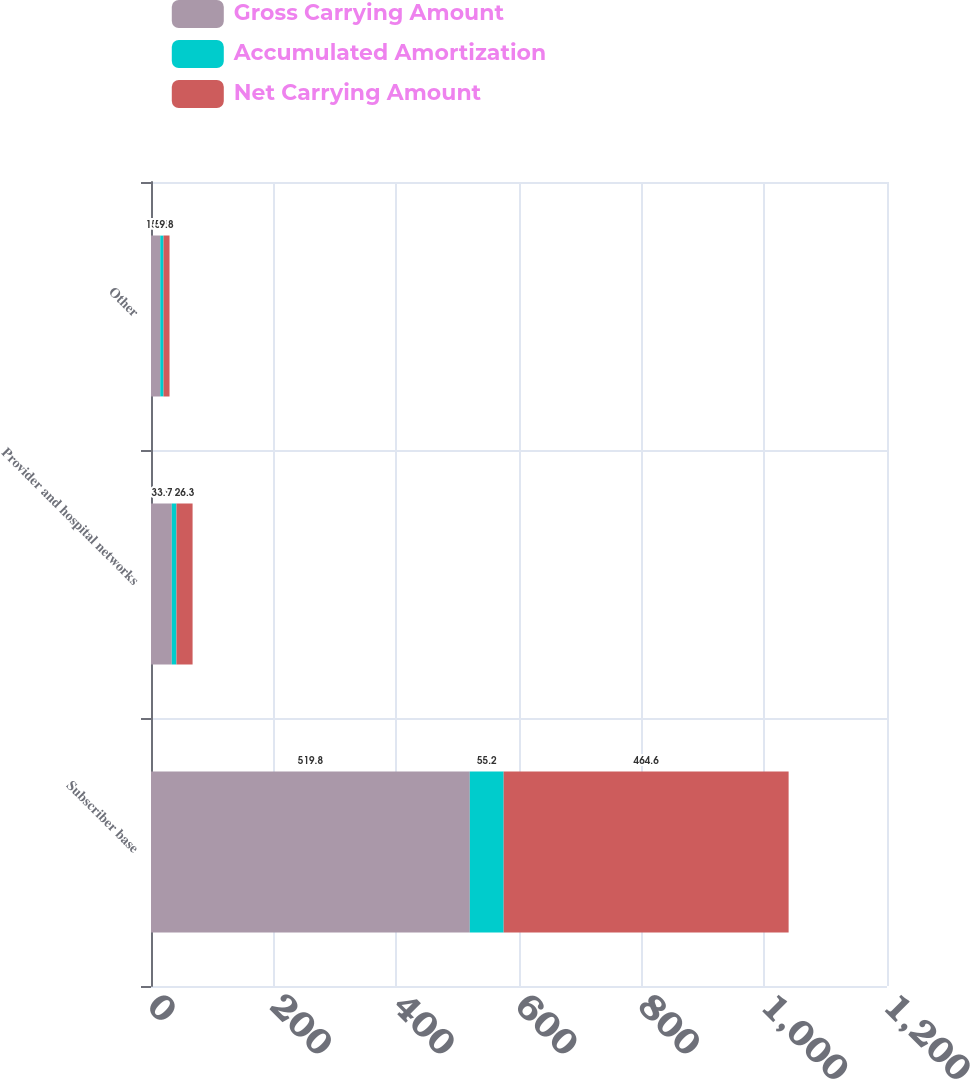Convert chart to OTSL. <chart><loc_0><loc_0><loc_500><loc_500><stacked_bar_chart><ecel><fcel>Subscriber base<fcel>Provider and hospital networks<fcel>Other<nl><fcel>Gross Carrying Amount<fcel>519.8<fcel>33.9<fcel>15.1<nl><fcel>Accumulated Amortization<fcel>55.2<fcel>7.6<fcel>5.3<nl><fcel>Net Carrying Amount<fcel>464.6<fcel>26.3<fcel>9.8<nl></chart> 